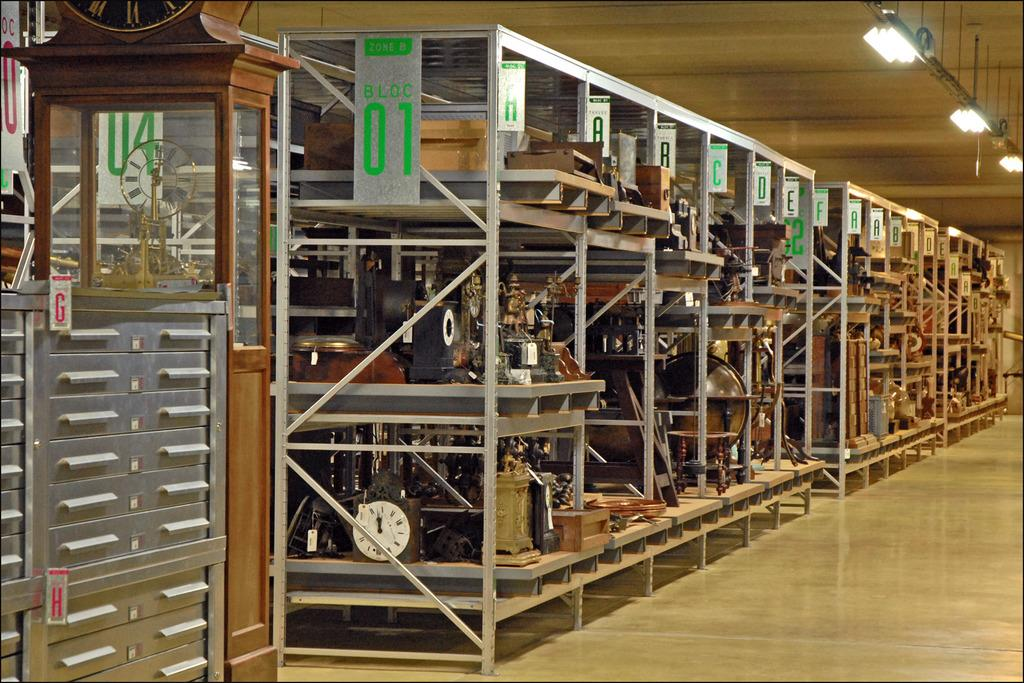<image>
Describe the image concisely. a warehouse with shelves numbered block 01 and A, B 